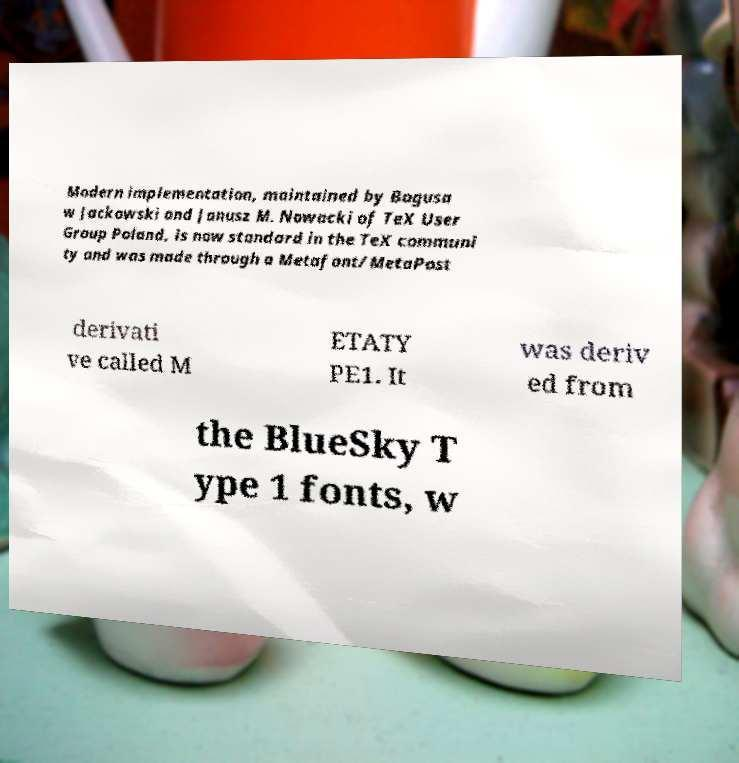For documentation purposes, I need the text within this image transcribed. Could you provide that? Modern implementation, maintained by Bogusa w Jackowski and Janusz M. Nowacki of TeX User Group Poland, is now standard in the TeX communi ty and was made through a Metafont/MetaPost derivati ve called M ETATY PE1. It was deriv ed from the BlueSky T ype 1 fonts, w 